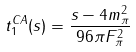<formula> <loc_0><loc_0><loc_500><loc_500>t _ { 1 } ^ { C A } ( s ) = { \frac { s - 4 m _ { \pi } ^ { 2 } } { 9 6 \pi F _ { \pi } ^ { 2 } } }</formula> 